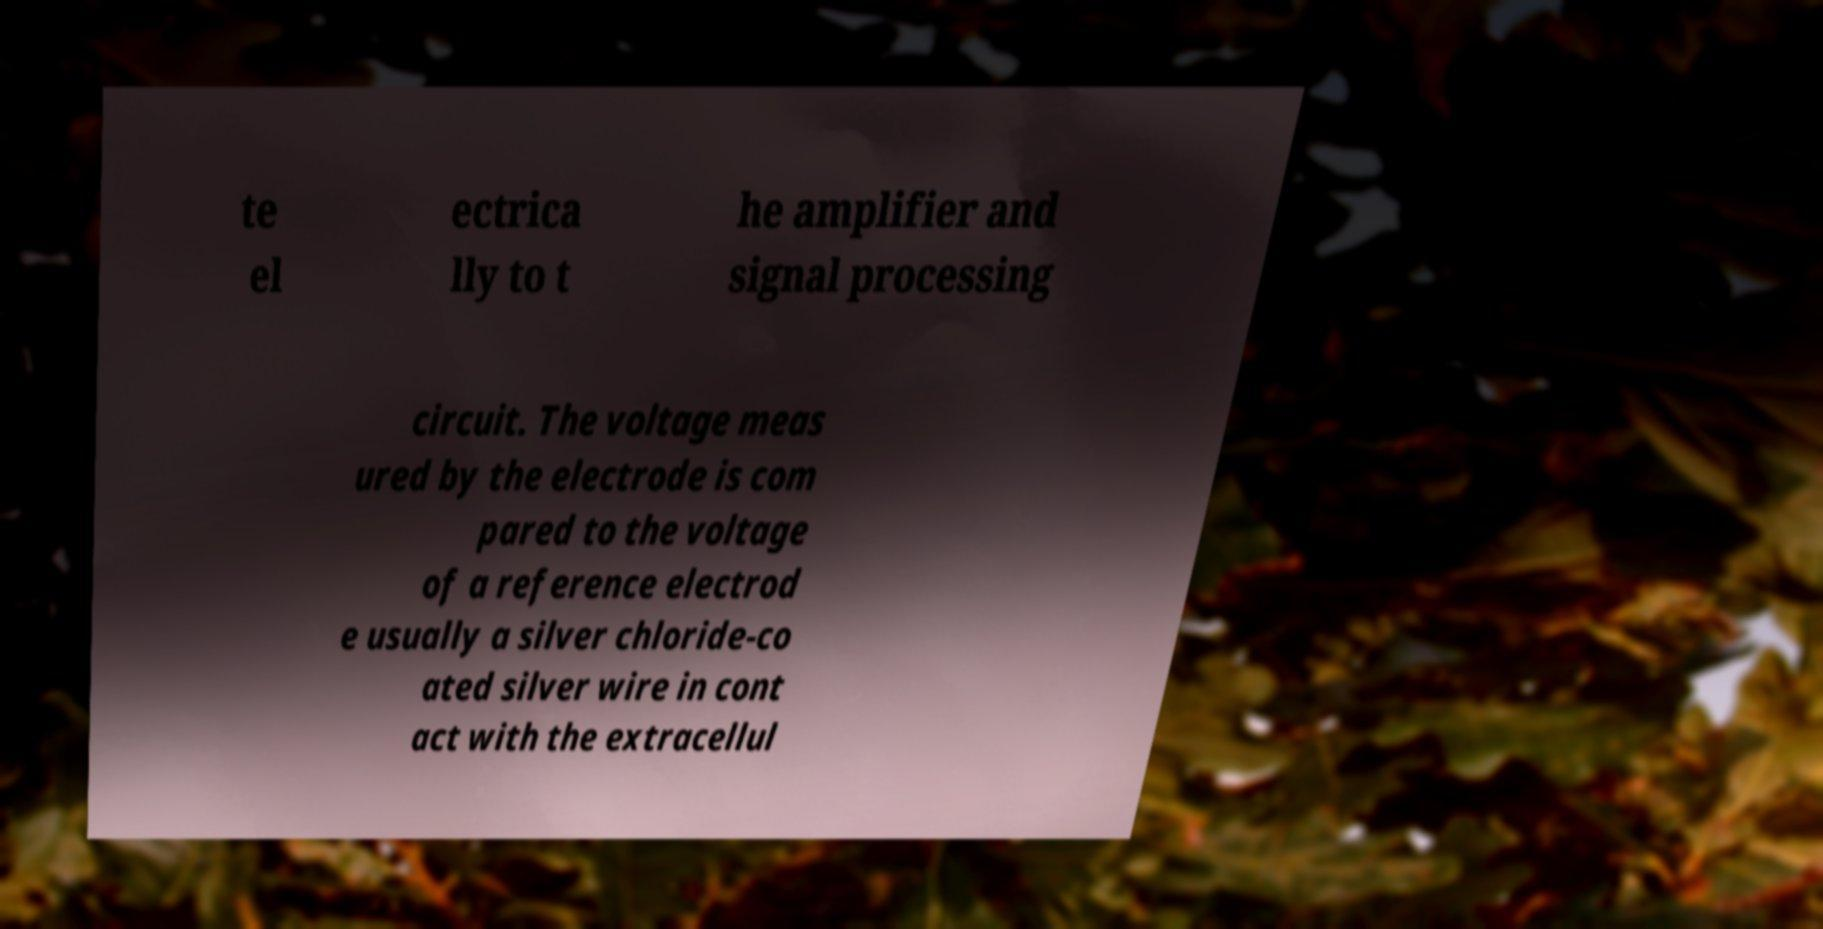Could you assist in decoding the text presented in this image and type it out clearly? te el ectrica lly to t he amplifier and signal processing circuit. The voltage meas ured by the electrode is com pared to the voltage of a reference electrod e usually a silver chloride-co ated silver wire in cont act with the extracellul 